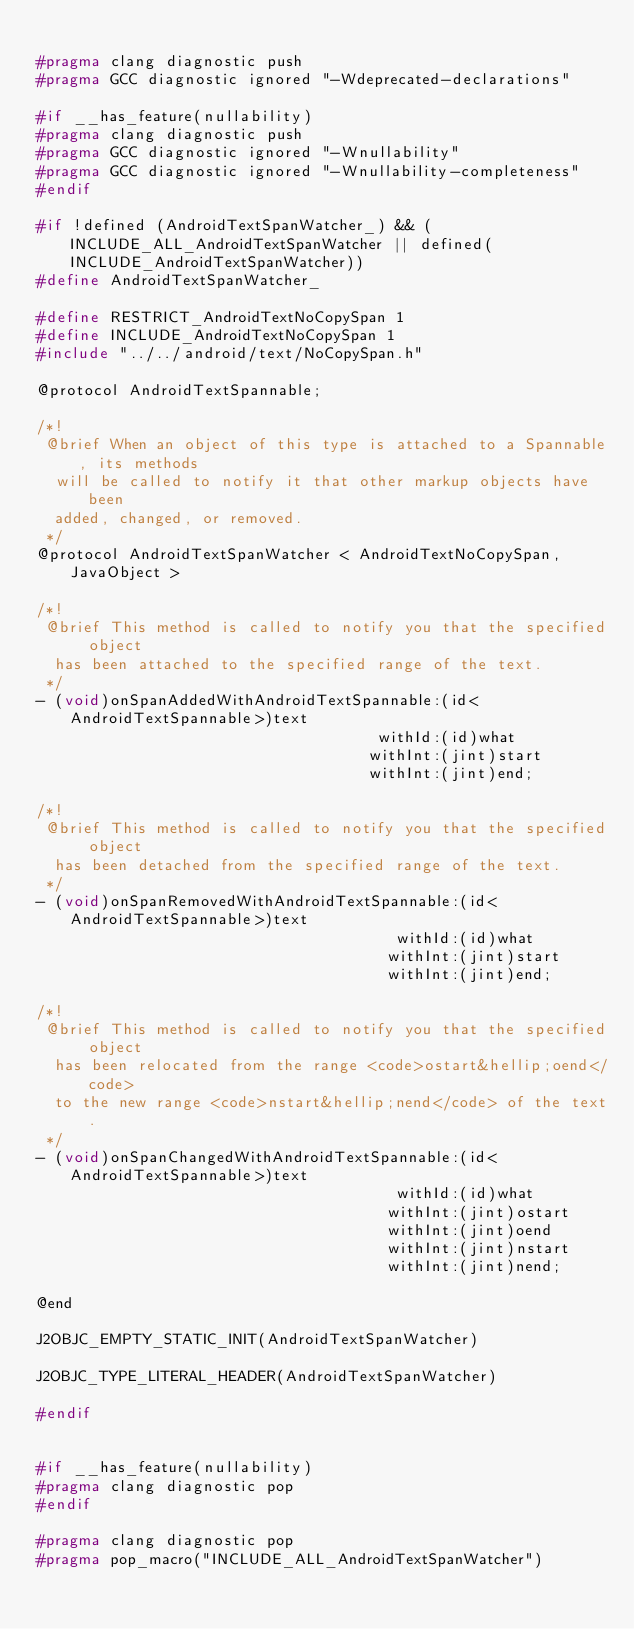<code> <loc_0><loc_0><loc_500><loc_500><_C_>
#pragma clang diagnostic push
#pragma GCC diagnostic ignored "-Wdeprecated-declarations"

#if __has_feature(nullability)
#pragma clang diagnostic push
#pragma GCC diagnostic ignored "-Wnullability"
#pragma GCC diagnostic ignored "-Wnullability-completeness"
#endif

#if !defined (AndroidTextSpanWatcher_) && (INCLUDE_ALL_AndroidTextSpanWatcher || defined(INCLUDE_AndroidTextSpanWatcher))
#define AndroidTextSpanWatcher_

#define RESTRICT_AndroidTextNoCopySpan 1
#define INCLUDE_AndroidTextNoCopySpan 1
#include "../../android/text/NoCopySpan.h"

@protocol AndroidTextSpannable;

/*!
 @brief When an object of this type is attached to a Spannable, its methods
  will be called to notify it that other markup objects have been
  added, changed, or removed.
 */
@protocol AndroidTextSpanWatcher < AndroidTextNoCopySpan, JavaObject >

/*!
 @brief This method is called to notify you that the specified object
  has been attached to the specified range of the text.
 */
- (void)onSpanAddedWithAndroidTextSpannable:(id<AndroidTextSpannable>)text
                                     withId:(id)what
                                    withInt:(jint)start
                                    withInt:(jint)end;

/*!
 @brief This method is called to notify you that the specified object
  has been detached from the specified range of the text.
 */
- (void)onSpanRemovedWithAndroidTextSpannable:(id<AndroidTextSpannable>)text
                                       withId:(id)what
                                      withInt:(jint)start
                                      withInt:(jint)end;

/*!
 @brief This method is called to notify you that the specified object
  has been relocated from the range <code>ostart&hellip;oend</code>
  to the new range <code>nstart&hellip;nend</code> of the text.
 */
- (void)onSpanChangedWithAndroidTextSpannable:(id<AndroidTextSpannable>)text
                                       withId:(id)what
                                      withInt:(jint)ostart
                                      withInt:(jint)oend
                                      withInt:(jint)nstart
                                      withInt:(jint)nend;

@end

J2OBJC_EMPTY_STATIC_INIT(AndroidTextSpanWatcher)

J2OBJC_TYPE_LITERAL_HEADER(AndroidTextSpanWatcher)

#endif


#if __has_feature(nullability)
#pragma clang diagnostic pop
#endif

#pragma clang diagnostic pop
#pragma pop_macro("INCLUDE_ALL_AndroidTextSpanWatcher")
</code> 